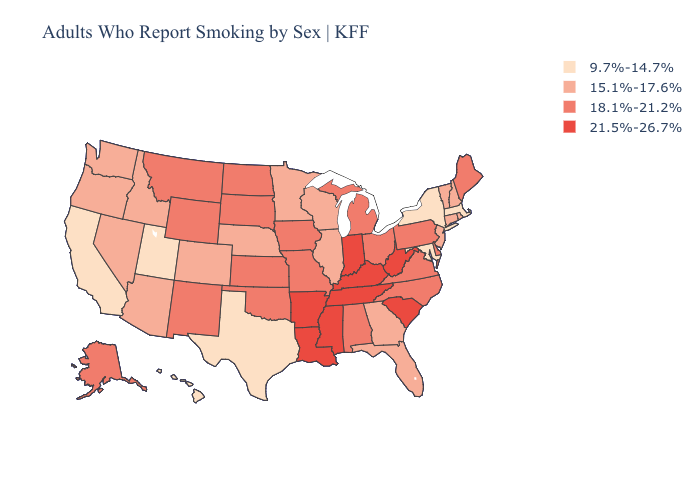Does Kentucky have the highest value in the South?
Keep it brief. Yes. Does Indiana have the lowest value in the USA?
Be succinct. No. Among the states that border California , which have the lowest value?
Quick response, please. Arizona, Nevada, Oregon. How many symbols are there in the legend?
Quick response, please. 4. Does Texas have the lowest value in the USA?
Keep it brief. Yes. Name the states that have a value in the range 18.1%-21.2%?
Answer briefly. Alabama, Alaska, Delaware, Iowa, Kansas, Maine, Michigan, Missouri, Montana, New Mexico, North Carolina, North Dakota, Ohio, Oklahoma, Pennsylvania, South Dakota, Virginia, Wyoming. Which states have the lowest value in the MidWest?
Quick response, please. Illinois, Minnesota, Nebraska, Wisconsin. Name the states that have a value in the range 18.1%-21.2%?
Write a very short answer. Alabama, Alaska, Delaware, Iowa, Kansas, Maine, Michigan, Missouri, Montana, New Mexico, North Carolina, North Dakota, Ohio, Oklahoma, Pennsylvania, South Dakota, Virginia, Wyoming. Does the map have missing data?
Be succinct. No. Does Nevada have the lowest value in the West?
Concise answer only. No. What is the value of West Virginia?
Keep it brief. 21.5%-26.7%. Which states have the highest value in the USA?
Be succinct. Arkansas, Indiana, Kentucky, Louisiana, Mississippi, South Carolina, Tennessee, West Virginia. What is the value of Wyoming?
Write a very short answer. 18.1%-21.2%. Does Indiana have the highest value in the MidWest?
Answer briefly. Yes. Name the states that have a value in the range 9.7%-14.7%?
Be succinct. California, Hawaii, Maryland, Massachusetts, New York, Texas, Utah. 